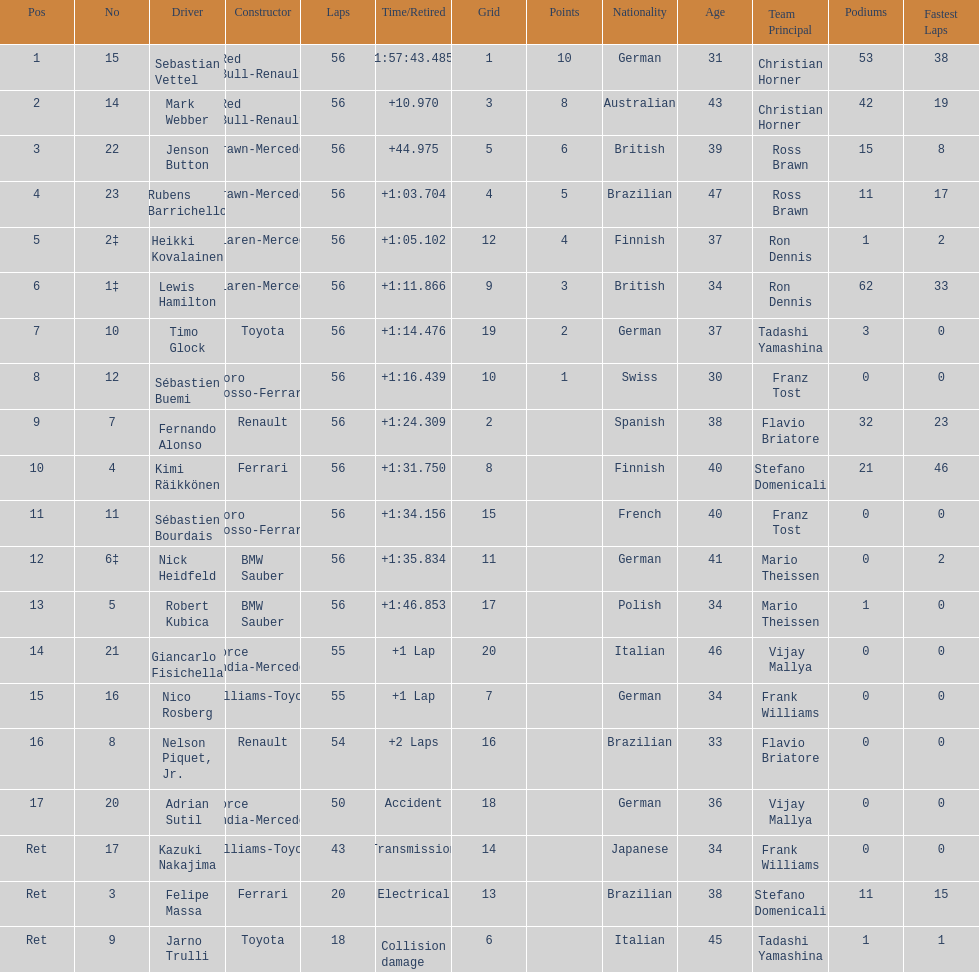How many drivers did not finish 56 laps? 7. 